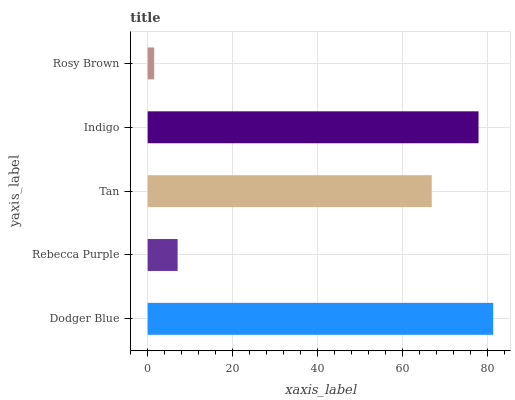Is Rosy Brown the minimum?
Answer yes or no. Yes. Is Dodger Blue the maximum?
Answer yes or no. Yes. Is Rebecca Purple the minimum?
Answer yes or no. No. Is Rebecca Purple the maximum?
Answer yes or no. No. Is Dodger Blue greater than Rebecca Purple?
Answer yes or no. Yes. Is Rebecca Purple less than Dodger Blue?
Answer yes or no. Yes. Is Rebecca Purple greater than Dodger Blue?
Answer yes or no. No. Is Dodger Blue less than Rebecca Purple?
Answer yes or no. No. Is Tan the high median?
Answer yes or no. Yes. Is Tan the low median?
Answer yes or no. Yes. Is Rosy Brown the high median?
Answer yes or no. No. Is Rebecca Purple the low median?
Answer yes or no. No. 